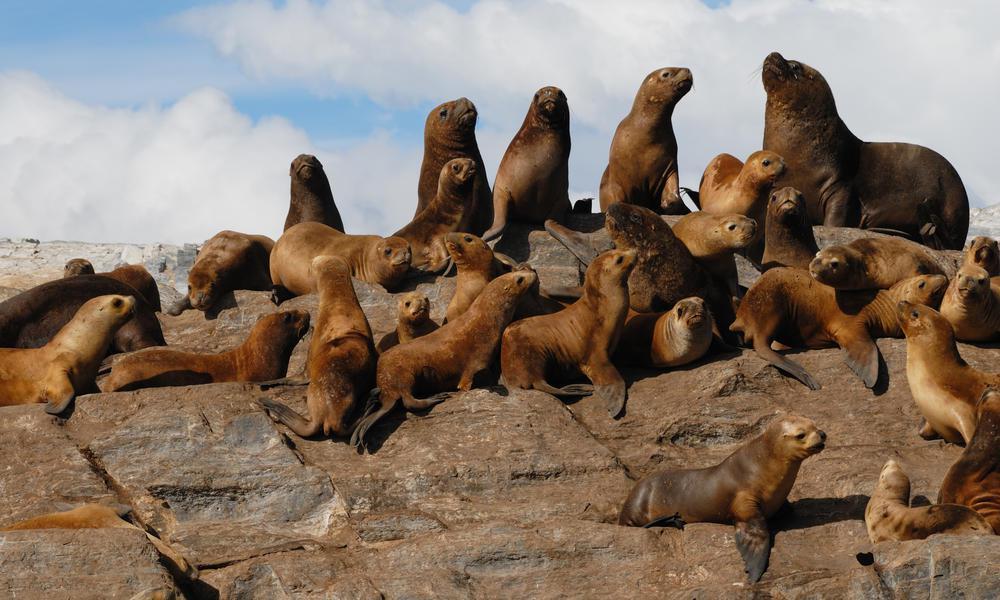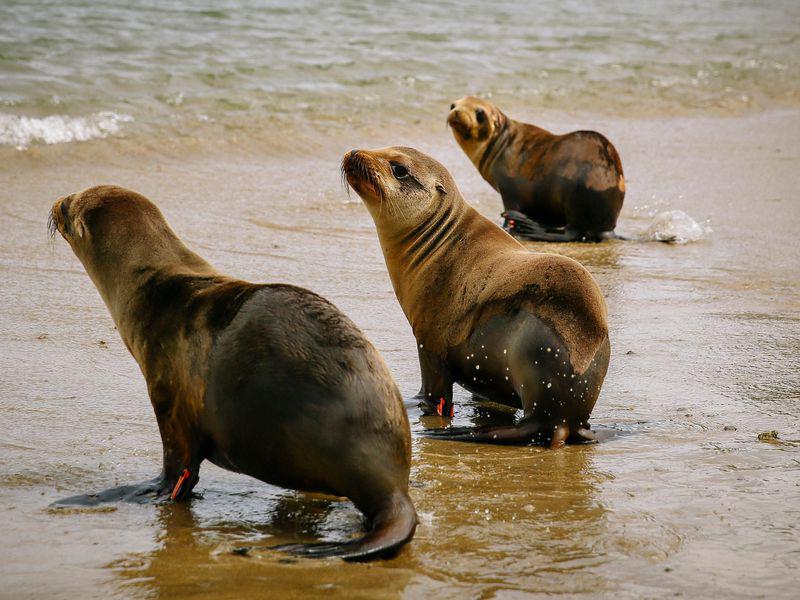The first image is the image on the left, the second image is the image on the right. Considering the images on both sides, is "No image shows more than two seals." valid? Answer yes or no. No. The first image is the image on the left, the second image is the image on the right. Analyze the images presented: Is the assertion "One image contains exactly three seals." valid? Answer yes or no. Yes. 